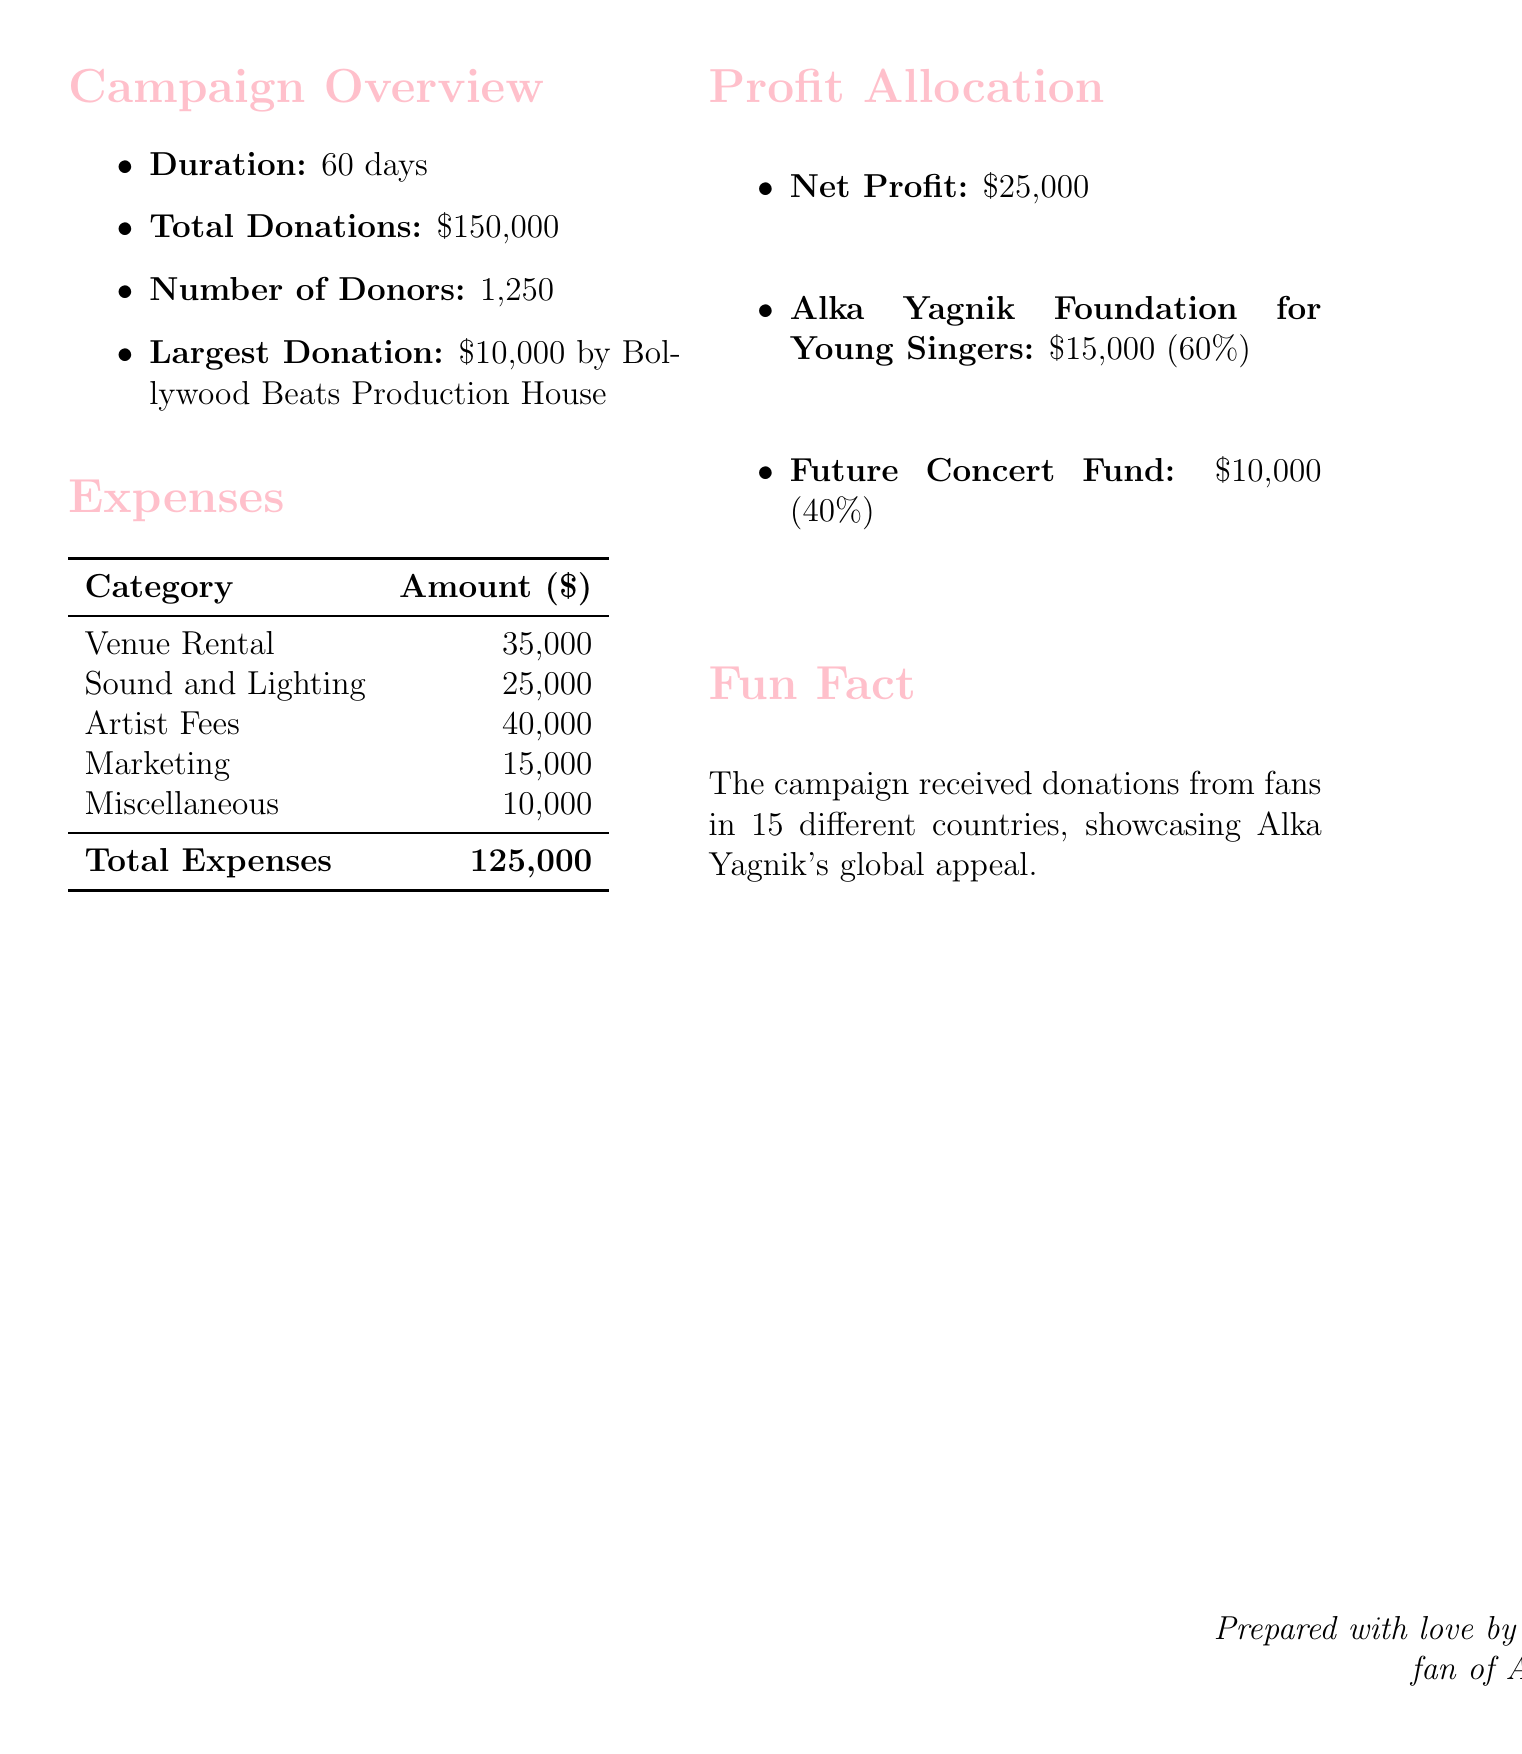What is the campaign name? The campaign name is provided at the top of the document, indicating the event being reported on.
Answer: Alka Yagnik Tribute Concert: A Night of Melody How long did the campaign last? The duration of the campaign is stated in the overview section.
Answer: 60 days What was the total amount of donations received? The total donations figure is highlighted in the campaign overview.
Answer: 150000 Who made the largest donation? The largest donation details, including the donor's name, are mentioned in the document.
Answer: Bollywood Beats Production House What was the total amount spent on the concert? The total expenses are outlined clearly in the expenses section of the report.
Answer: 125000 What percentage of the net profit goes to the Alka Yagnik Foundation? The document lists the profit allocation and percentages for each recipient.
Answer: 60 How much money was allocated to the Future Concert Fund? The allocation to the Future Concert Fund is specified in the profit allocation section.
Answer: 10000 How many countries contributed to the campaign? The fun fact section indicates the number of countries involved in the donations.
Answer: 15 